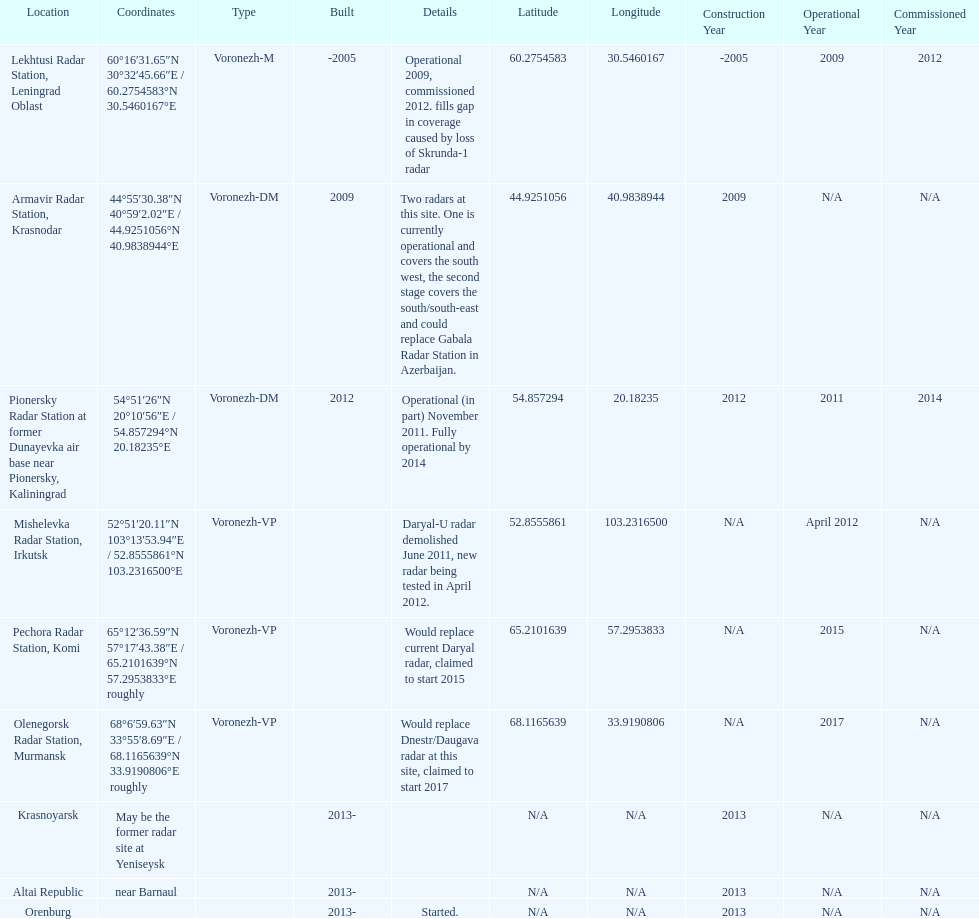What is the total number of locations? 9. 